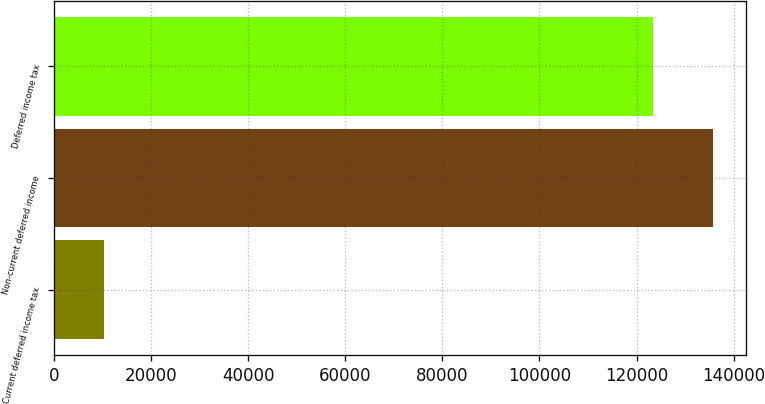Convert chart to OTSL. <chart><loc_0><loc_0><loc_500><loc_500><bar_chart><fcel>Current deferred income tax<fcel>Non-current deferred income<fcel>Deferred income tax<nl><fcel>10397<fcel>135700<fcel>123364<nl></chart> 